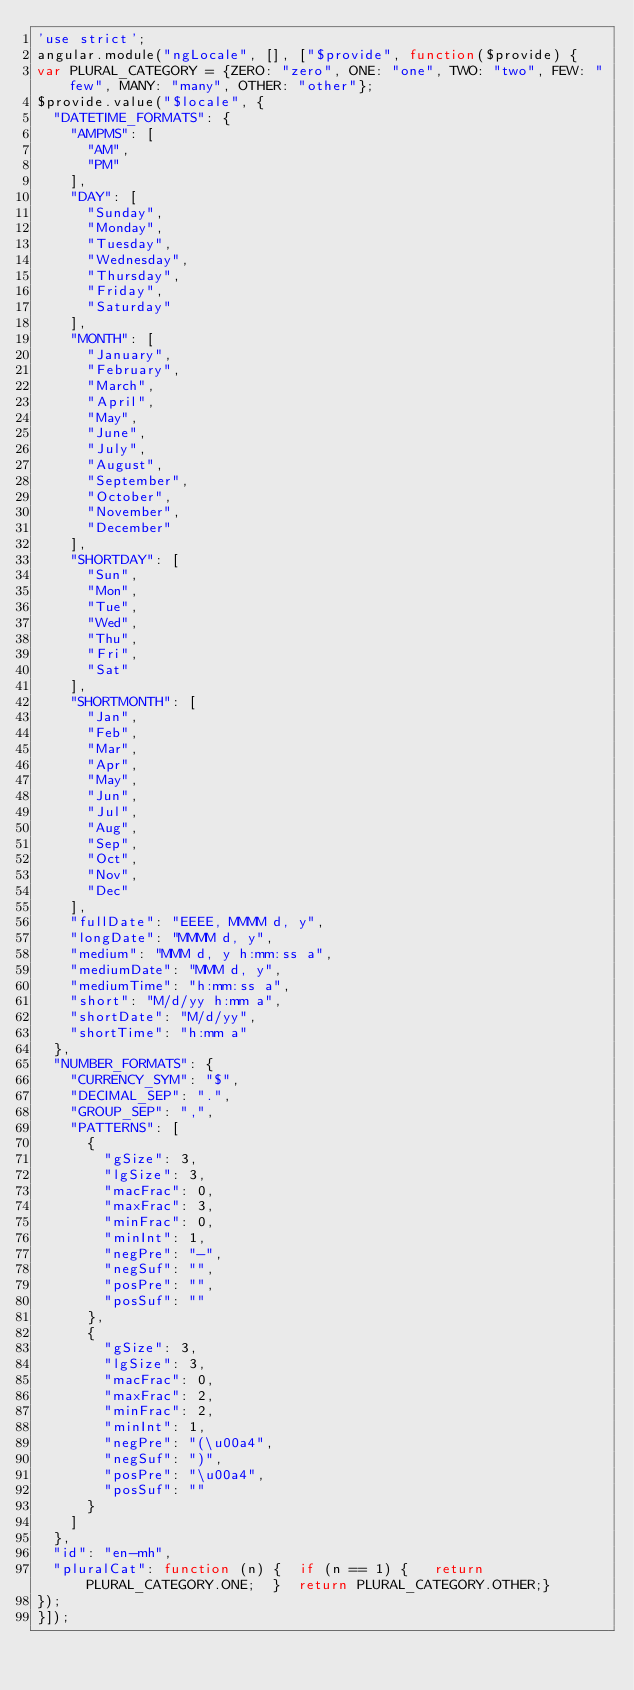Convert code to text. <code><loc_0><loc_0><loc_500><loc_500><_JavaScript_>'use strict';
angular.module("ngLocale", [], ["$provide", function($provide) {
var PLURAL_CATEGORY = {ZERO: "zero", ONE: "one", TWO: "two", FEW: "few", MANY: "many", OTHER: "other"};
$provide.value("$locale", {
  "DATETIME_FORMATS": {
    "AMPMS": [
      "AM",
      "PM"
    ],
    "DAY": [
      "Sunday",
      "Monday",
      "Tuesday",
      "Wednesday",
      "Thursday",
      "Friday",
      "Saturday"
    ],
    "MONTH": [
      "January",
      "February",
      "March",
      "April",
      "May",
      "June",
      "July",
      "August",
      "September",
      "October",
      "November",
      "December"
    ],
    "SHORTDAY": [
      "Sun",
      "Mon",
      "Tue",
      "Wed",
      "Thu",
      "Fri",
      "Sat"
    ],
    "SHORTMONTH": [
      "Jan",
      "Feb",
      "Mar",
      "Apr",
      "May",
      "Jun",
      "Jul",
      "Aug",
      "Sep",
      "Oct",
      "Nov",
      "Dec"
    ],
    "fullDate": "EEEE, MMMM d, y",
    "longDate": "MMMM d, y",
    "medium": "MMM d, y h:mm:ss a",
    "mediumDate": "MMM d, y",
    "mediumTime": "h:mm:ss a",
    "short": "M/d/yy h:mm a",
    "shortDate": "M/d/yy",
    "shortTime": "h:mm a"
  },
  "NUMBER_FORMATS": {
    "CURRENCY_SYM": "$",
    "DECIMAL_SEP": ".",
    "GROUP_SEP": ",",
    "PATTERNS": [
      {
        "gSize": 3,
        "lgSize": 3,
        "macFrac": 0,
        "maxFrac": 3,
        "minFrac": 0,
        "minInt": 1,
        "negPre": "-",
        "negSuf": "",
        "posPre": "",
        "posSuf": ""
      },
      {
        "gSize": 3,
        "lgSize": 3,
        "macFrac": 0,
        "maxFrac": 2,
        "minFrac": 2,
        "minInt": 1,
        "negPre": "(\u00a4",
        "negSuf": ")",
        "posPre": "\u00a4",
        "posSuf": ""
      }
    ]
  },
  "id": "en-mh",
  "pluralCat": function (n) {  if (n == 1) {   return PLURAL_CATEGORY.ONE;  }  return PLURAL_CATEGORY.OTHER;}
});
}]);</code> 